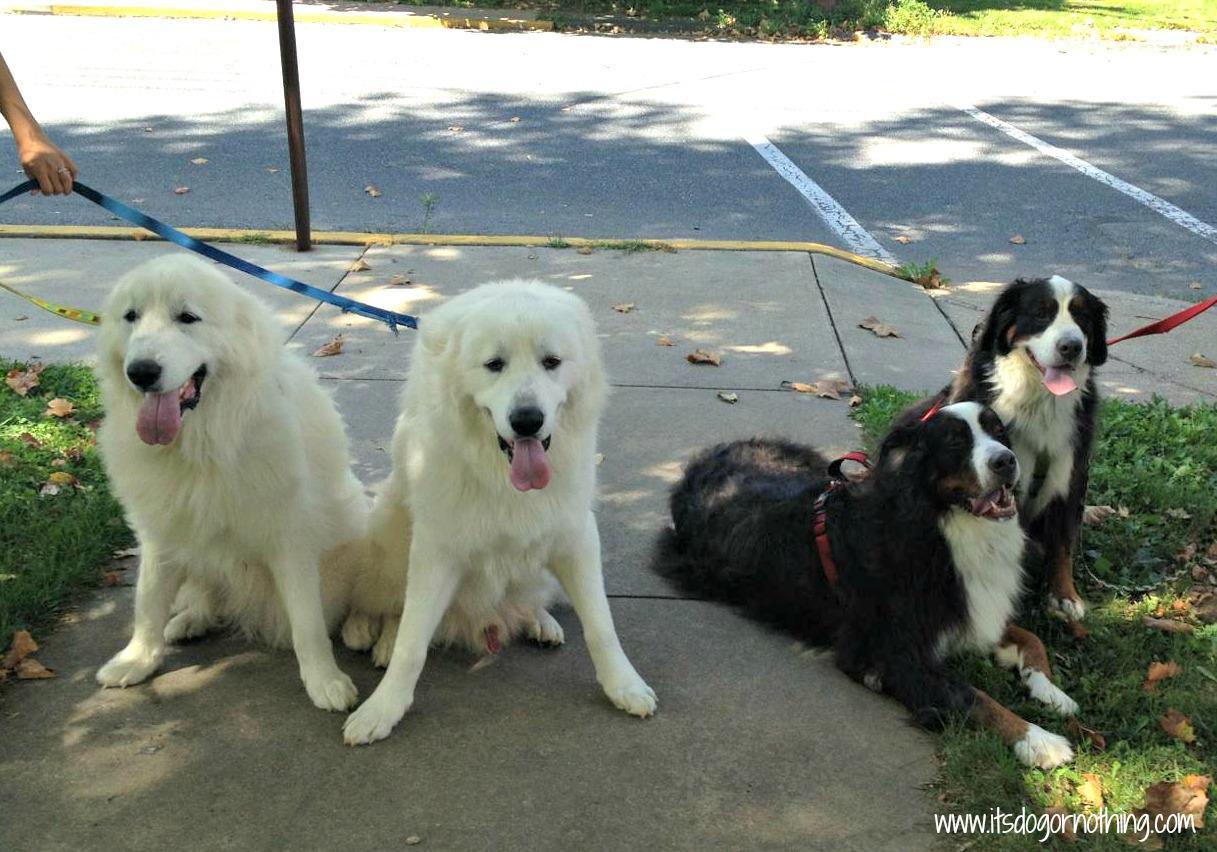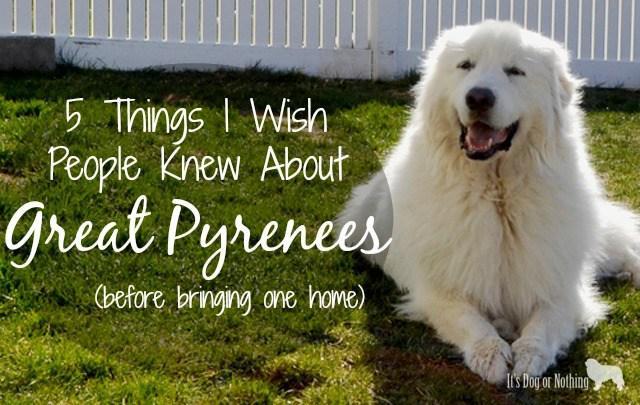The first image is the image on the left, the second image is the image on the right. Given the left and right images, does the statement "The dog in the image on the right is lying in the grass outside." hold true? Answer yes or no. Yes. The first image is the image on the left, the second image is the image on the right. Analyze the images presented: Is the assertion "Each image shows one dog which is standing on all fours." valid? Answer yes or no. No. 